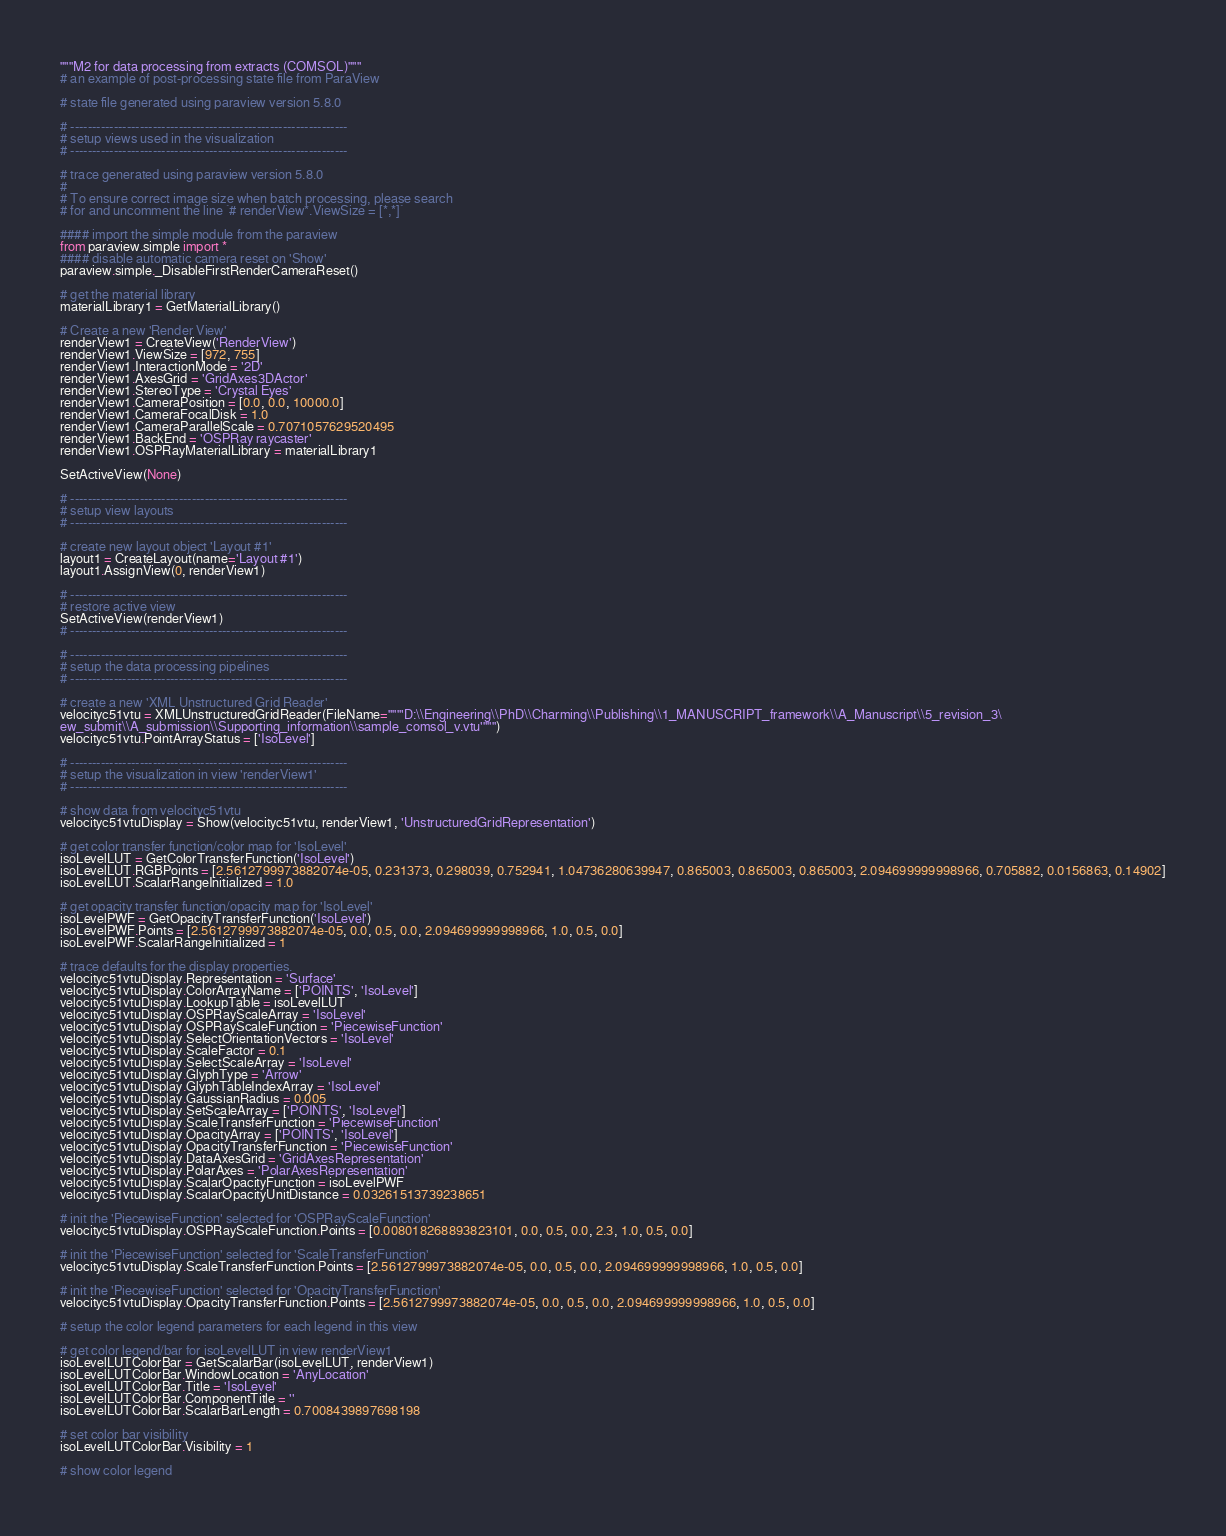Convert code to text. <code><loc_0><loc_0><loc_500><loc_500><_Python_>"""M2 for data processing from extracts (COMSOL)"""
# an example of post-processing state file from ParaView

# state file generated using paraview version 5.8.0

# ----------------------------------------------------------------
# setup views used in the visualization
# ----------------------------------------------------------------

# trace generated using paraview version 5.8.0
#
# To ensure correct image size when batch processing, please search 
# for and uncomment the line `# renderView*.ViewSize = [*,*]`

#### import the simple module from the paraview
from paraview.simple import *
#### disable automatic camera reset on 'Show'
paraview.simple._DisableFirstRenderCameraReset()

# get the material library
materialLibrary1 = GetMaterialLibrary()

# Create a new 'Render View'
renderView1 = CreateView('RenderView')
renderView1.ViewSize = [972, 755]
renderView1.InteractionMode = '2D'
renderView1.AxesGrid = 'GridAxes3DActor'
renderView1.StereoType = 'Crystal Eyes'
renderView1.CameraPosition = [0.0, 0.0, 10000.0]
renderView1.CameraFocalDisk = 1.0
renderView1.CameraParallelScale = 0.7071057629520495
renderView1.BackEnd = 'OSPRay raycaster'
renderView1.OSPRayMaterialLibrary = materialLibrary1

SetActiveView(None)

# ----------------------------------------------------------------
# setup view layouts
# ----------------------------------------------------------------

# create new layout object 'Layout #1'
layout1 = CreateLayout(name='Layout #1')
layout1.AssignView(0, renderView1)

# ----------------------------------------------------------------
# restore active view
SetActiveView(renderView1)
# ----------------------------------------------------------------

# ----------------------------------------------------------------
# setup the data processing pipelines
# ----------------------------------------------------------------

# create a new 'XML Unstructured Grid Reader'
velocityc51vtu = XMLUnstructuredGridReader(FileName="""'D:\\Engineering\\PhD\\Charming\\Publishing\\1_MANUSCRIPT_framework\\A_Manuscript\\5_revision_3\
ew_submit\\A_submission\\Supporting_information\\sample_comsol_v.vtu'""")
velocityc51vtu.PointArrayStatus = ['IsoLevel']

# ----------------------------------------------------------------
# setup the visualization in view 'renderView1'
# ----------------------------------------------------------------

# show data from velocityc51vtu
velocityc51vtuDisplay = Show(velocityc51vtu, renderView1, 'UnstructuredGridRepresentation')

# get color transfer function/color map for 'IsoLevel'
isoLevelLUT = GetColorTransferFunction('IsoLevel')
isoLevelLUT.RGBPoints = [2.5612799973882074e-05, 0.231373, 0.298039, 0.752941, 1.04736280639947, 0.865003, 0.865003, 0.865003, 2.094699999998966, 0.705882, 0.0156863, 0.14902]
isoLevelLUT.ScalarRangeInitialized = 1.0

# get opacity transfer function/opacity map for 'IsoLevel'
isoLevelPWF = GetOpacityTransferFunction('IsoLevel')
isoLevelPWF.Points = [2.5612799973882074e-05, 0.0, 0.5, 0.0, 2.094699999998966, 1.0, 0.5, 0.0]
isoLevelPWF.ScalarRangeInitialized = 1

# trace defaults for the display properties.
velocityc51vtuDisplay.Representation = 'Surface'
velocityc51vtuDisplay.ColorArrayName = ['POINTS', 'IsoLevel']
velocityc51vtuDisplay.LookupTable = isoLevelLUT
velocityc51vtuDisplay.OSPRayScaleArray = 'IsoLevel'
velocityc51vtuDisplay.OSPRayScaleFunction = 'PiecewiseFunction'
velocityc51vtuDisplay.SelectOrientationVectors = 'IsoLevel'
velocityc51vtuDisplay.ScaleFactor = 0.1
velocityc51vtuDisplay.SelectScaleArray = 'IsoLevel'
velocityc51vtuDisplay.GlyphType = 'Arrow'
velocityc51vtuDisplay.GlyphTableIndexArray = 'IsoLevel'
velocityc51vtuDisplay.GaussianRadius = 0.005
velocityc51vtuDisplay.SetScaleArray = ['POINTS', 'IsoLevel']
velocityc51vtuDisplay.ScaleTransferFunction = 'PiecewiseFunction'
velocityc51vtuDisplay.OpacityArray = ['POINTS', 'IsoLevel']
velocityc51vtuDisplay.OpacityTransferFunction = 'PiecewiseFunction'
velocityc51vtuDisplay.DataAxesGrid = 'GridAxesRepresentation'
velocityc51vtuDisplay.PolarAxes = 'PolarAxesRepresentation'
velocityc51vtuDisplay.ScalarOpacityFunction = isoLevelPWF
velocityc51vtuDisplay.ScalarOpacityUnitDistance = 0.03261513739238651

# init the 'PiecewiseFunction' selected for 'OSPRayScaleFunction'
velocityc51vtuDisplay.OSPRayScaleFunction.Points = [0.008018268893823101, 0.0, 0.5, 0.0, 2.3, 1.0, 0.5, 0.0]

# init the 'PiecewiseFunction' selected for 'ScaleTransferFunction'
velocityc51vtuDisplay.ScaleTransferFunction.Points = [2.5612799973882074e-05, 0.0, 0.5, 0.0, 2.094699999998966, 1.0, 0.5, 0.0]

# init the 'PiecewiseFunction' selected for 'OpacityTransferFunction'
velocityc51vtuDisplay.OpacityTransferFunction.Points = [2.5612799973882074e-05, 0.0, 0.5, 0.0, 2.094699999998966, 1.0, 0.5, 0.0]

# setup the color legend parameters for each legend in this view

# get color legend/bar for isoLevelLUT in view renderView1
isoLevelLUTColorBar = GetScalarBar(isoLevelLUT, renderView1)
isoLevelLUTColorBar.WindowLocation = 'AnyLocation'
isoLevelLUTColorBar.Title = 'IsoLevel'
isoLevelLUTColorBar.ComponentTitle = ''
isoLevelLUTColorBar.ScalarBarLength = 0.7008439897698198

# set color bar visibility
isoLevelLUTColorBar.Visibility = 1

# show color legend</code> 